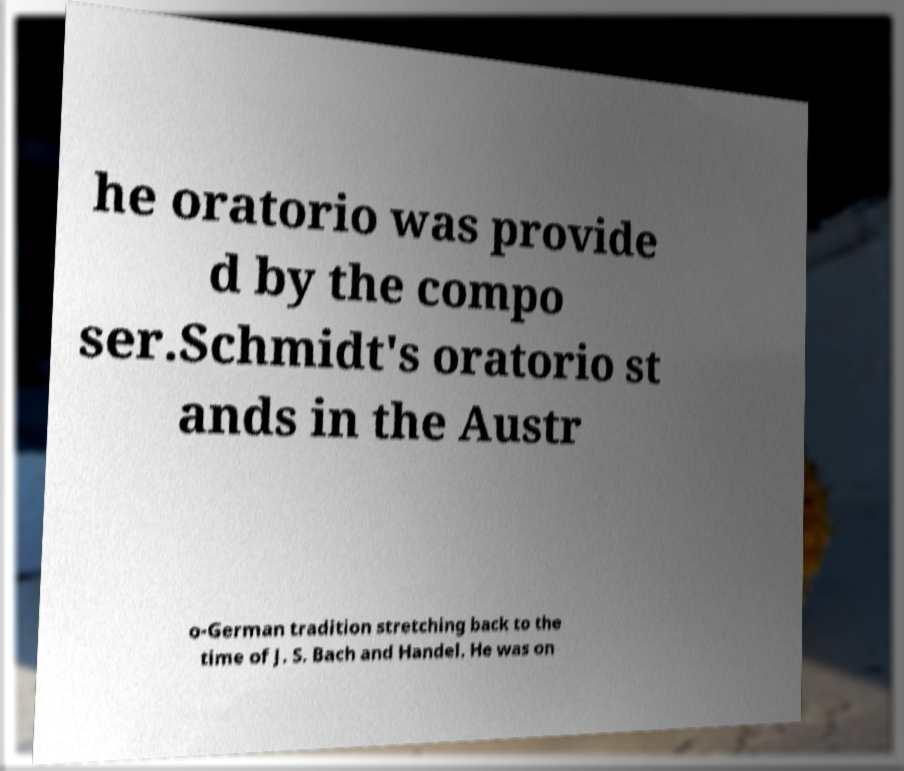Could you assist in decoding the text presented in this image and type it out clearly? he oratorio was provide d by the compo ser.Schmidt's oratorio st ands in the Austr o-German tradition stretching back to the time of J. S. Bach and Handel. He was on 